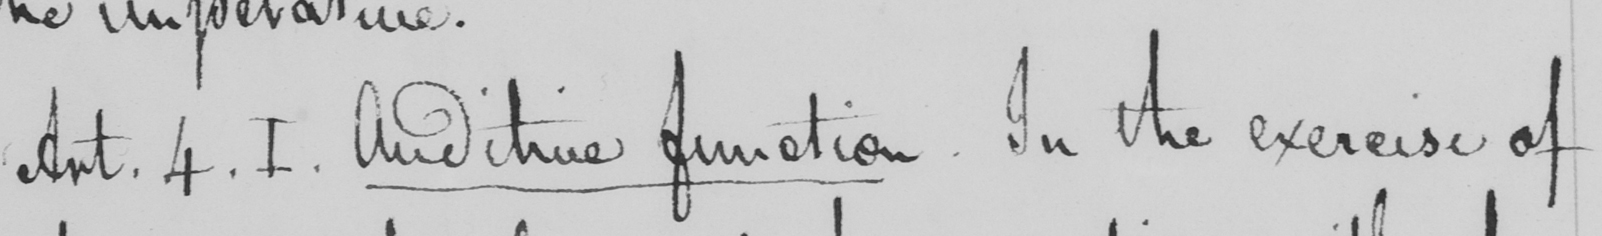What does this handwritten line say? Art . 4 . I . Auditive function . In the exercise of 